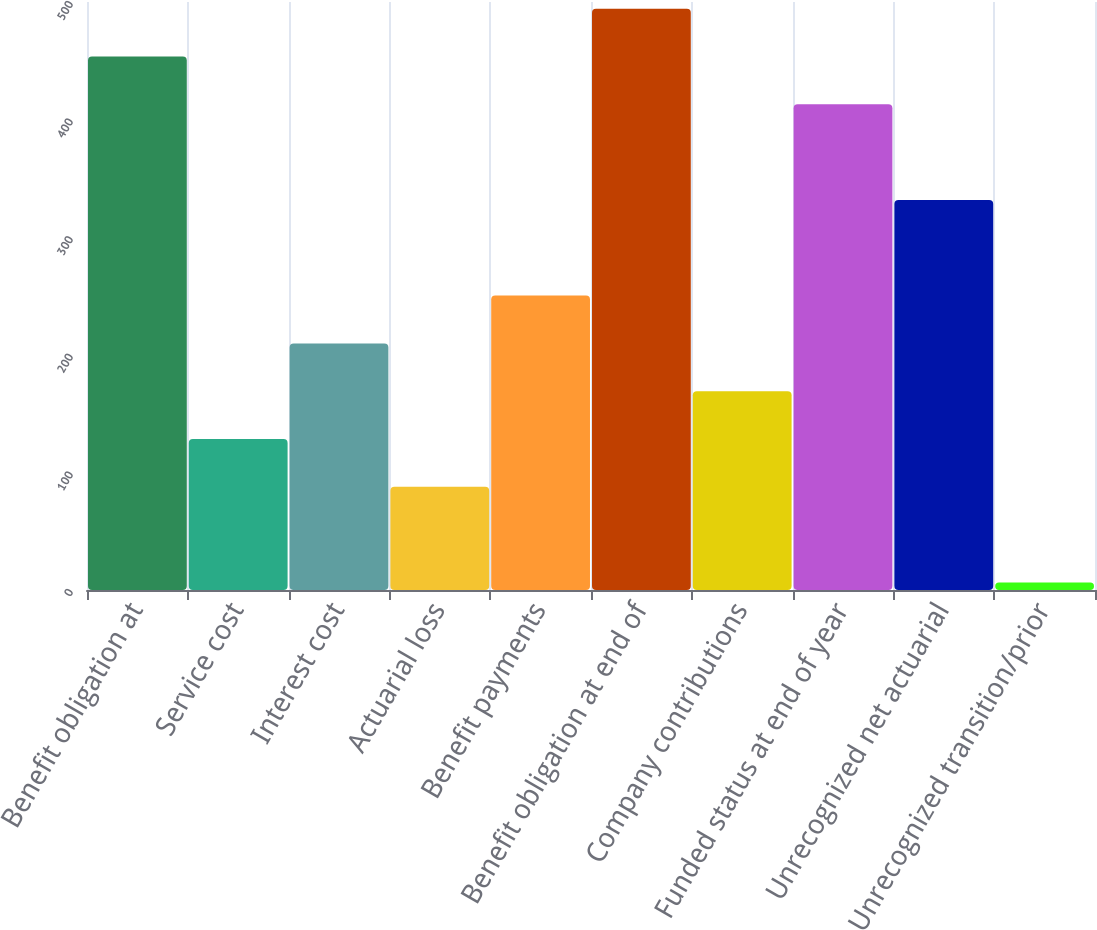<chart> <loc_0><loc_0><loc_500><loc_500><bar_chart><fcel>Benefit obligation at<fcel>Service cost<fcel>Interest cost<fcel>Actuarial loss<fcel>Benefit payments<fcel>Benefit obligation at end of<fcel>Company contributions<fcel>Funded status at end of year<fcel>Unrecognized net actuarial<fcel>Unrecognized transition/prior<nl><fcel>453.66<fcel>128.38<fcel>209.7<fcel>87.72<fcel>250.36<fcel>494.32<fcel>169.04<fcel>413<fcel>331.68<fcel>6.4<nl></chart> 